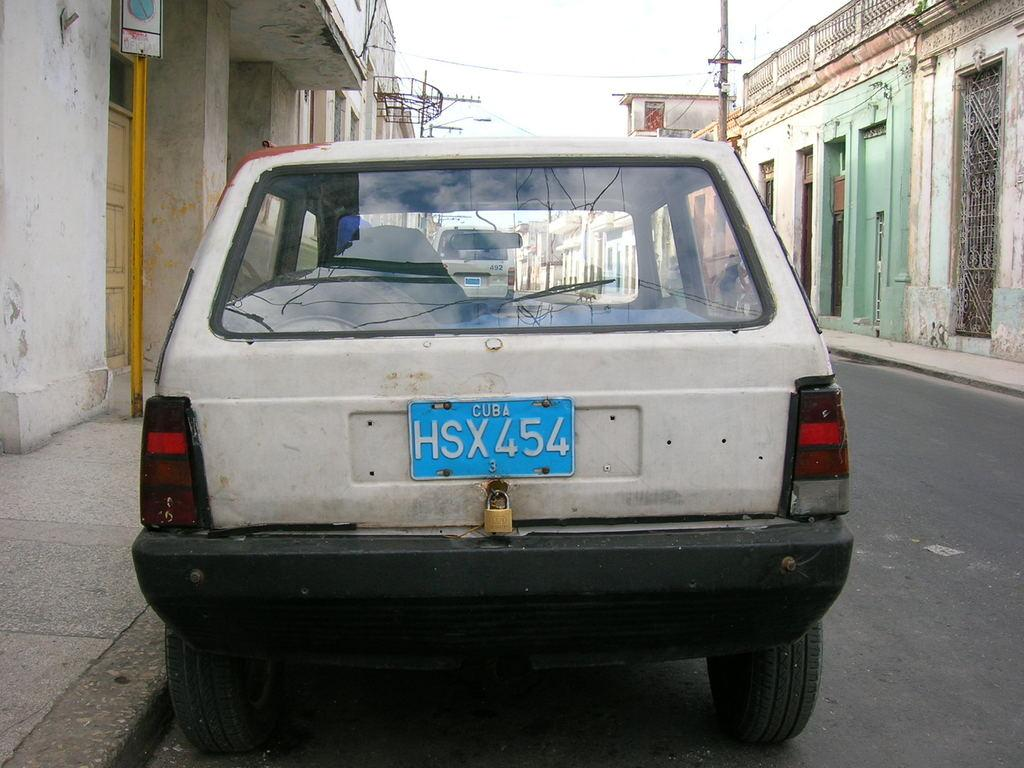What type of vehicles can be seen on the road in the image? There are cars on the road in the image. What can be seen in the background of the image? There are buildings and poles in the background of the image. What type of destruction can be seen in the image? There is no destruction present in the image; it features cars on the road and buildings and poles in the background. Can you tell me which minister is present in the image? There is no minister present in the image. 